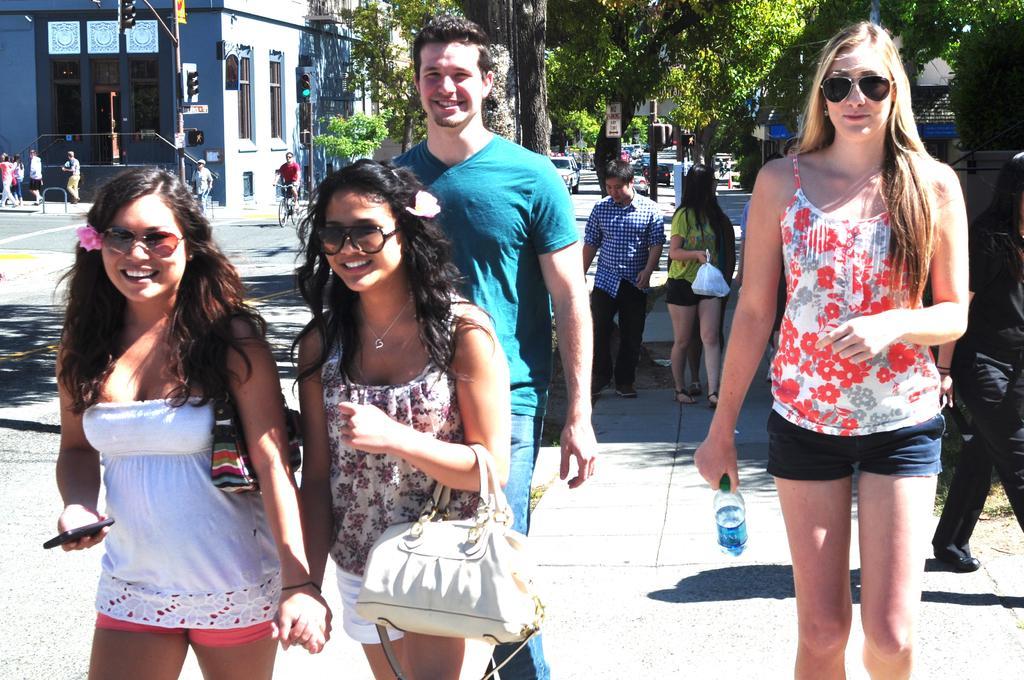Could you give a brief overview of what you see in this image? This picture shows a group of people standing and holding water bottle in their hand and we see couple of trees and a building and we see a man riding bicycle 